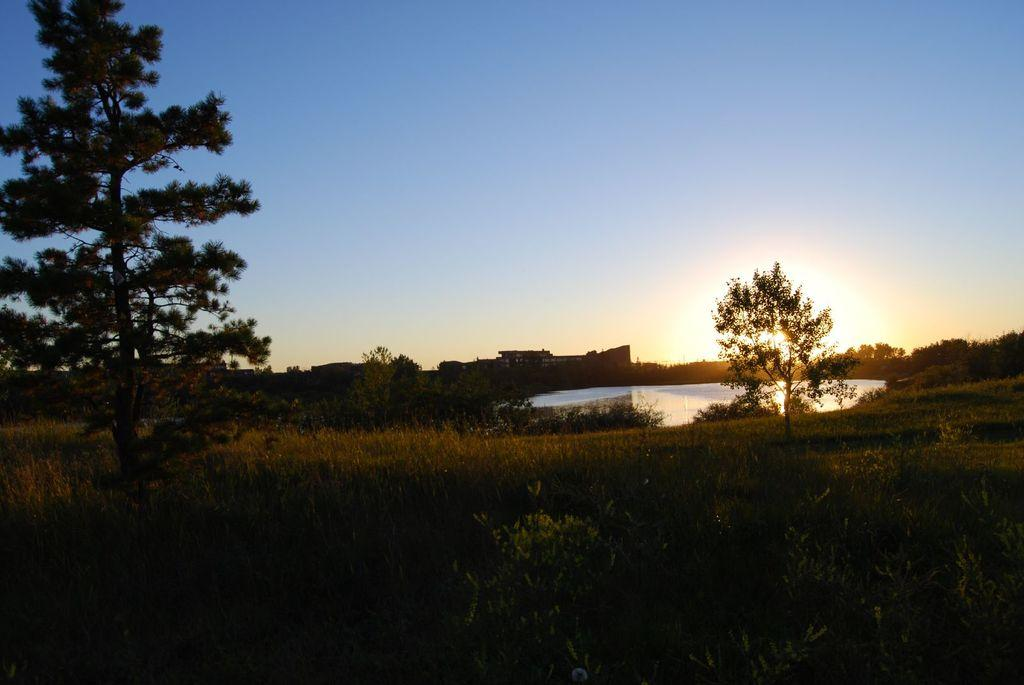What type of vegetation can be seen in the image? There are trees and plants in the image. What can be seen in the background of the image? Water and the sky are visible in the background of the image. Can you describe the natural environment in the image? The image features trees, plants, water, and the sky, suggesting a natural setting. What direction are the trees facing in the image? The direction the trees are facing cannot be determined from the image, as trees do not have a specific direction they face. 